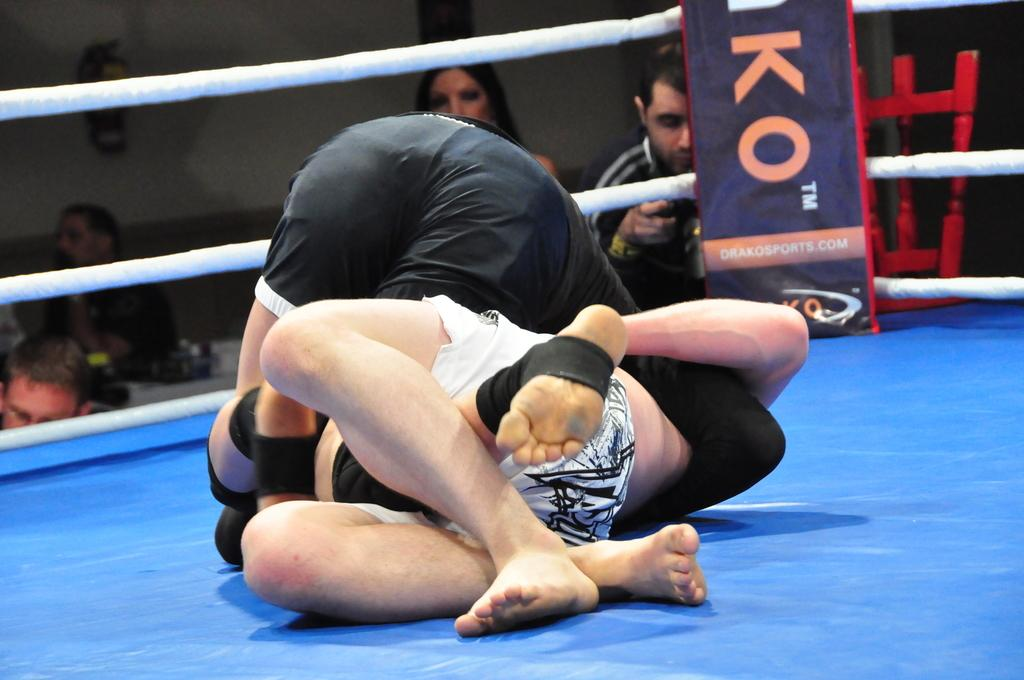<image>
Present a compact description of the photo's key features. Two wrestlers on a blue mat with the letter KO behind them. 